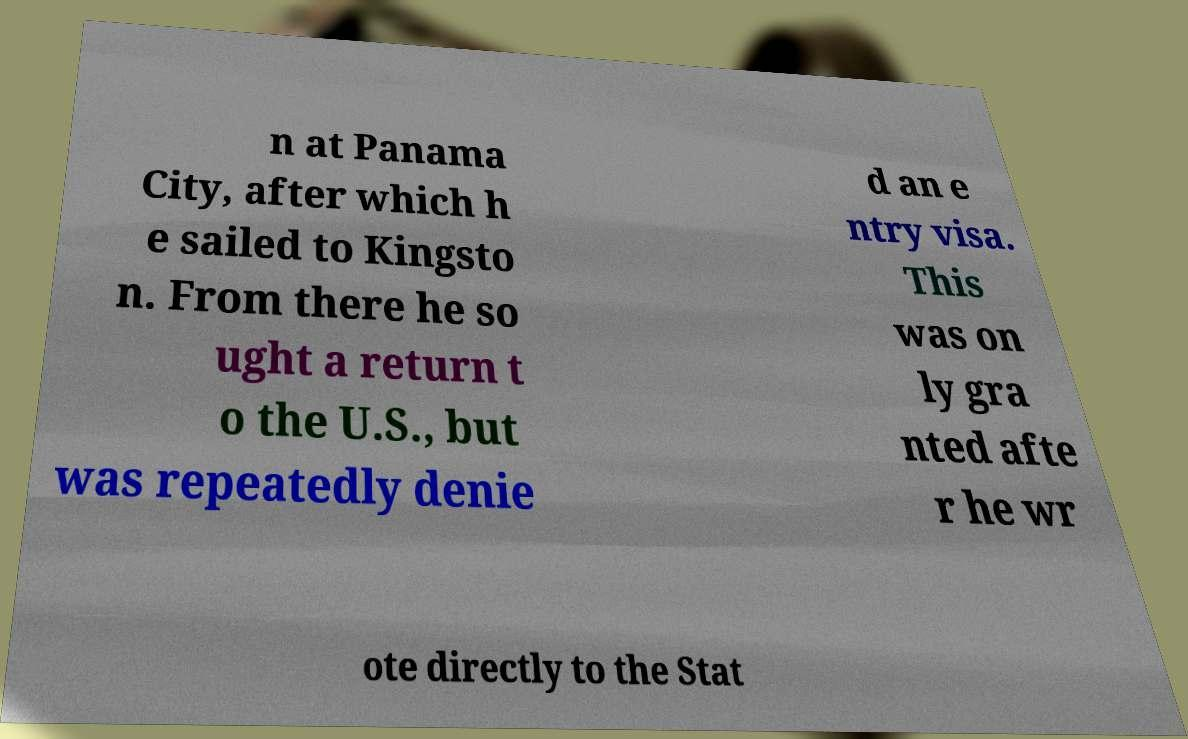Can you read and provide the text displayed in the image?This photo seems to have some interesting text. Can you extract and type it out for me? n at Panama City, after which h e sailed to Kingsto n. From there he so ught a return t o the U.S., but was repeatedly denie d an e ntry visa. This was on ly gra nted afte r he wr ote directly to the Stat 